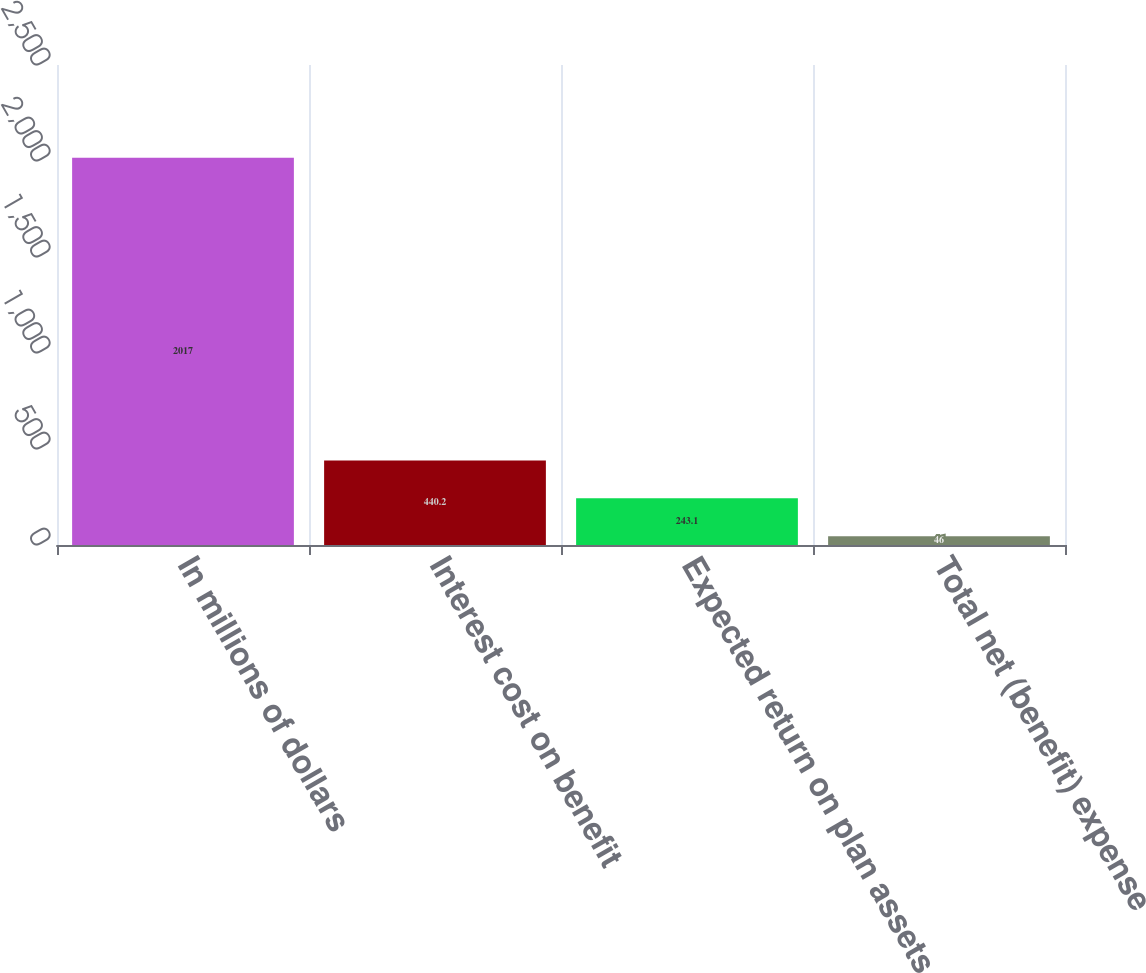Convert chart. <chart><loc_0><loc_0><loc_500><loc_500><bar_chart><fcel>In millions of dollars<fcel>Interest cost on benefit<fcel>Expected return on plan assets<fcel>Total net (benefit) expense<nl><fcel>2017<fcel>440.2<fcel>243.1<fcel>46<nl></chart> 